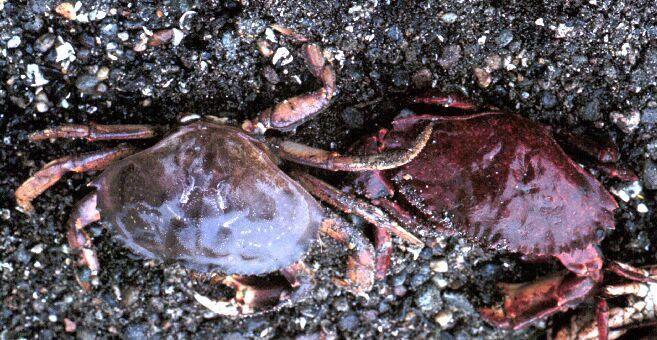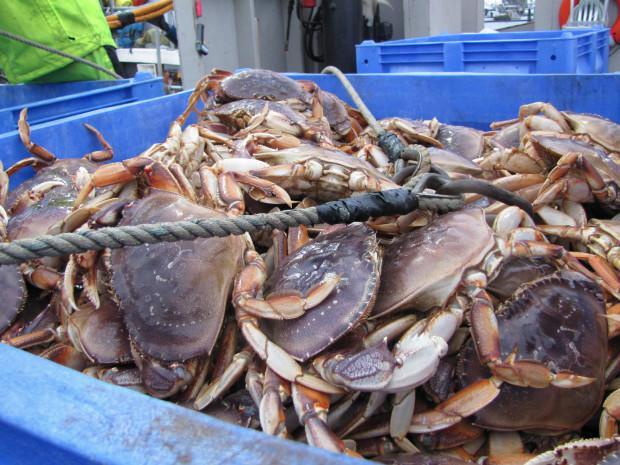The first image is the image on the left, the second image is the image on the right. For the images displayed, is the sentence "The crabs in the image on the right are sitting in a brightly colored container." factually correct? Answer yes or no. Yes. The first image is the image on the left, the second image is the image on the right. For the images displayed, is the sentence "There are cables wrapping around the outside of the crate the crabs are in." factually correct? Answer yes or no. Yes. 